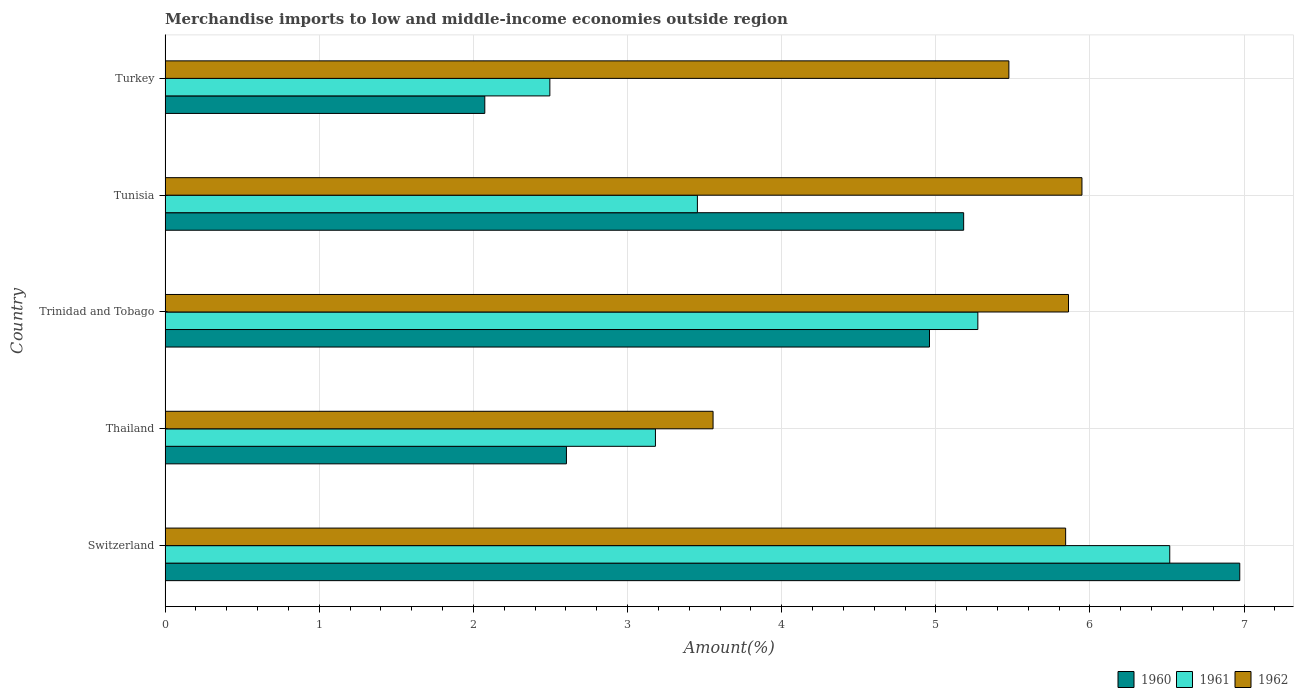How many different coloured bars are there?
Give a very brief answer. 3. Are the number of bars per tick equal to the number of legend labels?
Provide a short and direct response. Yes. How many bars are there on the 4th tick from the top?
Provide a succinct answer. 3. What is the label of the 1st group of bars from the top?
Make the answer very short. Turkey. What is the percentage of amount earned from merchandise imports in 1962 in Turkey?
Your answer should be very brief. 5.47. Across all countries, what is the maximum percentage of amount earned from merchandise imports in 1960?
Provide a short and direct response. 6.97. Across all countries, what is the minimum percentage of amount earned from merchandise imports in 1960?
Offer a very short reply. 2.07. In which country was the percentage of amount earned from merchandise imports in 1962 maximum?
Keep it short and to the point. Tunisia. What is the total percentage of amount earned from merchandise imports in 1962 in the graph?
Provide a short and direct response. 26.68. What is the difference between the percentage of amount earned from merchandise imports in 1962 in Trinidad and Tobago and that in Turkey?
Your answer should be very brief. 0.39. What is the difference between the percentage of amount earned from merchandise imports in 1961 in Thailand and the percentage of amount earned from merchandise imports in 1960 in Tunisia?
Offer a very short reply. -2. What is the average percentage of amount earned from merchandise imports in 1960 per country?
Give a very brief answer. 4.36. What is the difference between the percentage of amount earned from merchandise imports in 1961 and percentage of amount earned from merchandise imports in 1962 in Thailand?
Your answer should be very brief. -0.37. In how many countries, is the percentage of amount earned from merchandise imports in 1960 greater than 1.6 %?
Offer a very short reply. 5. What is the ratio of the percentage of amount earned from merchandise imports in 1962 in Thailand to that in Turkey?
Give a very brief answer. 0.65. Is the difference between the percentage of amount earned from merchandise imports in 1961 in Tunisia and Turkey greater than the difference between the percentage of amount earned from merchandise imports in 1962 in Tunisia and Turkey?
Keep it short and to the point. Yes. What is the difference between the highest and the second highest percentage of amount earned from merchandise imports in 1960?
Keep it short and to the point. 1.79. What is the difference between the highest and the lowest percentage of amount earned from merchandise imports in 1960?
Provide a short and direct response. 4.9. How many countries are there in the graph?
Keep it short and to the point. 5. Does the graph contain grids?
Provide a succinct answer. Yes. How are the legend labels stacked?
Ensure brevity in your answer.  Horizontal. What is the title of the graph?
Your answer should be compact. Merchandise imports to low and middle-income economies outside region. What is the label or title of the X-axis?
Offer a very short reply. Amount(%). What is the Amount(%) in 1960 in Switzerland?
Make the answer very short. 6.97. What is the Amount(%) in 1961 in Switzerland?
Give a very brief answer. 6.52. What is the Amount(%) of 1962 in Switzerland?
Provide a succinct answer. 5.84. What is the Amount(%) of 1960 in Thailand?
Provide a succinct answer. 2.6. What is the Amount(%) in 1961 in Thailand?
Keep it short and to the point. 3.18. What is the Amount(%) of 1962 in Thailand?
Provide a succinct answer. 3.55. What is the Amount(%) of 1960 in Trinidad and Tobago?
Make the answer very short. 4.96. What is the Amount(%) in 1961 in Trinidad and Tobago?
Offer a terse response. 5.27. What is the Amount(%) in 1962 in Trinidad and Tobago?
Ensure brevity in your answer.  5.86. What is the Amount(%) in 1960 in Tunisia?
Your answer should be compact. 5.18. What is the Amount(%) in 1961 in Tunisia?
Provide a succinct answer. 3.45. What is the Amount(%) in 1962 in Tunisia?
Provide a short and direct response. 5.95. What is the Amount(%) in 1960 in Turkey?
Provide a short and direct response. 2.07. What is the Amount(%) in 1961 in Turkey?
Make the answer very short. 2.5. What is the Amount(%) in 1962 in Turkey?
Give a very brief answer. 5.47. Across all countries, what is the maximum Amount(%) in 1960?
Ensure brevity in your answer.  6.97. Across all countries, what is the maximum Amount(%) of 1961?
Offer a very short reply. 6.52. Across all countries, what is the maximum Amount(%) of 1962?
Provide a short and direct response. 5.95. Across all countries, what is the minimum Amount(%) in 1960?
Offer a very short reply. 2.07. Across all countries, what is the minimum Amount(%) in 1961?
Offer a very short reply. 2.5. Across all countries, what is the minimum Amount(%) of 1962?
Provide a short and direct response. 3.55. What is the total Amount(%) in 1960 in the graph?
Offer a very short reply. 21.79. What is the total Amount(%) in 1961 in the graph?
Give a very brief answer. 20.92. What is the total Amount(%) of 1962 in the graph?
Your response must be concise. 26.68. What is the difference between the Amount(%) of 1960 in Switzerland and that in Thailand?
Provide a short and direct response. 4.37. What is the difference between the Amount(%) in 1961 in Switzerland and that in Thailand?
Provide a short and direct response. 3.34. What is the difference between the Amount(%) of 1962 in Switzerland and that in Thailand?
Keep it short and to the point. 2.29. What is the difference between the Amount(%) in 1960 in Switzerland and that in Trinidad and Tobago?
Your answer should be compact. 2.01. What is the difference between the Amount(%) of 1961 in Switzerland and that in Trinidad and Tobago?
Your response must be concise. 1.25. What is the difference between the Amount(%) in 1962 in Switzerland and that in Trinidad and Tobago?
Your answer should be compact. -0.02. What is the difference between the Amount(%) of 1960 in Switzerland and that in Tunisia?
Offer a terse response. 1.79. What is the difference between the Amount(%) in 1961 in Switzerland and that in Tunisia?
Provide a short and direct response. 3.06. What is the difference between the Amount(%) of 1962 in Switzerland and that in Tunisia?
Offer a very short reply. -0.11. What is the difference between the Amount(%) of 1960 in Switzerland and that in Turkey?
Your response must be concise. 4.9. What is the difference between the Amount(%) of 1961 in Switzerland and that in Turkey?
Give a very brief answer. 4.02. What is the difference between the Amount(%) of 1962 in Switzerland and that in Turkey?
Ensure brevity in your answer.  0.37. What is the difference between the Amount(%) of 1960 in Thailand and that in Trinidad and Tobago?
Make the answer very short. -2.36. What is the difference between the Amount(%) in 1961 in Thailand and that in Trinidad and Tobago?
Provide a short and direct response. -2.09. What is the difference between the Amount(%) in 1962 in Thailand and that in Trinidad and Tobago?
Provide a succinct answer. -2.31. What is the difference between the Amount(%) of 1960 in Thailand and that in Tunisia?
Provide a succinct answer. -2.58. What is the difference between the Amount(%) in 1961 in Thailand and that in Tunisia?
Give a very brief answer. -0.27. What is the difference between the Amount(%) of 1962 in Thailand and that in Tunisia?
Your answer should be compact. -2.39. What is the difference between the Amount(%) in 1960 in Thailand and that in Turkey?
Offer a very short reply. 0.53. What is the difference between the Amount(%) of 1961 in Thailand and that in Turkey?
Keep it short and to the point. 0.69. What is the difference between the Amount(%) in 1962 in Thailand and that in Turkey?
Provide a short and direct response. -1.92. What is the difference between the Amount(%) in 1960 in Trinidad and Tobago and that in Tunisia?
Give a very brief answer. -0.22. What is the difference between the Amount(%) in 1961 in Trinidad and Tobago and that in Tunisia?
Your response must be concise. 1.82. What is the difference between the Amount(%) in 1962 in Trinidad and Tobago and that in Tunisia?
Keep it short and to the point. -0.09. What is the difference between the Amount(%) in 1960 in Trinidad and Tobago and that in Turkey?
Provide a short and direct response. 2.88. What is the difference between the Amount(%) in 1961 in Trinidad and Tobago and that in Turkey?
Offer a terse response. 2.78. What is the difference between the Amount(%) in 1962 in Trinidad and Tobago and that in Turkey?
Your answer should be compact. 0.39. What is the difference between the Amount(%) in 1960 in Tunisia and that in Turkey?
Provide a short and direct response. 3.11. What is the difference between the Amount(%) of 1961 in Tunisia and that in Turkey?
Give a very brief answer. 0.96. What is the difference between the Amount(%) in 1962 in Tunisia and that in Turkey?
Your response must be concise. 0.47. What is the difference between the Amount(%) in 1960 in Switzerland and the Amount(%) in 1961 in Thailand?
Offer a terse response. 3.79. What is the difference between the Amount(%) of 1960 in Switzerland and the Amount(%) of 1962 in Thailand?
Your answer should be compact. 3.42. What is the difference between the Amount(%) of 1961 in Switzerland and the Amount(%) of 1962 in Thailand?
Offer a very short reply. 2.96. What is the difference between the Amount(%) in 1960 in Switzerland and the Amount(%) in 1961 in Trinidad and Tobago?
Keep it short and to the point. 1.7. What is the difference between the Amount(%) in 1960 in Switzerland and the Amount(%) in 1962 in Trinidad and Tobago?
Make the answer very short. 1.11. What is the difference between the Amount(%) of 1961 in Switzerland and the Amount(%) of 1962 in Trinidad and Tobago?
Your answer should be very brief. 0.66. What is the difference between the Amount(%) in 1960 in Switzerland and the Amount(%) in 1961 in Tunisia?
Your answer should be compact. 3.52. What is the difference between the Amount(%) in 1960 in Switzerland and the Amount(%) in 1962 in Tunisia?
Keep it short and to the point. 1.02. What is the difference between the Amount(%) of 1961 in Switzerland and the Amount(%) of 1962 in Tunisia?
Offer a terse response. 0.57. What is the difference between the Amount(%) of 1960 in Switzerland and the Amount(%) of 1961 in Turkey?
Offer a terse response. 4.48. What is the difference between the Amount(%) of 1960 in Switzerland and the Amount(%) of 1962 in Turkey?
Ensure brevity in your answer.  1.5. What is the difference between the Amount(%) in 1961 in Switzerland and the Amount(%) in 1962 in Turkey?
Your response must be concise. 1.04. What is the difference between the Amount(%) in 1960 in Thailand and the Amount(%) in 1961 in Trinidad and Tobago?
Make the answer very short. -2.67. What is the difference between the Amount(%) in 1960 in Thailand and the Amount(%) in 1962 in Trinidad and Tobago?
Give a very brief answer. -3.26. What is the difference between the Amount(%) in 1961 in Thailand and the Amount(%) in 1962 in Trinidad and Tobago?
Make the answer very short. -2.68. What is the difference between the Amount(%) in 1960 in Thailand and the Amount(%) in 1961 in Tunisia?
Offer a very short reply. -0.85. What is the difference between the Amount(%) in 1960 in Thailand and the Amount(%) in 1962 in Tunisia?
Offer a very short reply. -3.34. What is the difference between the Amount(%) in 1961 in Thailand and the Amount(%) in 1962 in Tunisia?
Provide a short and direct response. -2.77. What is the difference between the Amount(%) of 1960 in Thailand and the Amount(%) of 1961 in Turkey?
Keep it short and to the point. 0.11. What is the difference between the Amount(%) in 1960 in Thailand and the Amount(%) in 1962 in Turkey?
Your answer should be compact. -2.87. What is the difference between the Amount(%) in 1961 in Thailand and the Amount(%) in 1962 in Turkey?
Provide a short and direct response. -2.29. What is the difference between the Amount(%) in 1960 in Trinidad and Tobago and the Amount(%) in 1961 in Tunisia?
Provide a succinct answer. 1.51. What is the difference between the Amount(%) in 1960 in Trinidad and Tobago and the Amount(%) in 1962 in Tunisia?
Offer a very short reply. -0.99. What is the difference between the Amount(%) in 1961 in Trinidad and Tobago and the Amount(%) in 1962 in Tunisia?
Give a very brief answer. -0.68. What is the difference between the Amount(%) in 1960 in Trinidad and Tobago and the Amount(%) in 1961 in Turkey?
Provide a short and direct response. 2.46. What is the difference between the Amount(%) in 1960 in Trinidad and Tobago and the Amount(%) in 1962 in Turkey?
Offer a terse response. -0.52. What is the difference between the Amount(%) in 1961 in Trinidad and Tobago and the Amount(%) in 1962 in Turkey?
Make the answer very short. -0.2. What is the difference between the Amount(%) of 1960 in Tunisia and the Amount(%) of 1961 in Turkey?
Offer a terse response. 2.68. What is the difference between the Amount(%) of 1960 in Tunisia and the Amount(%) of 1962 in Turkey?
Ensure brevity in your answer.  -0.29. What is the difference between the Amount(%) in 1961 in Tunisia and the Amount(%) in 1962 in Turkey?
Provide a short and direct response. -2.02. What is the average Amount(%) in 1960 per country?
Make the answer very short. 4.36. What is the average Amount(%) of 1961 per country?
Your answer should be very brief. 4.18. What is the average Amount(%) in 1962 per country?
Your response must be concise. 5.34. What is the difference between the Amount(%) of 1960 and Amount(%) of 1961 in Switzerland?
Offer a very short reply. 0.45. What is the difference between the Amount(%) of 1960 and Amount(%) of 1962 in Switzerland?
Offer a very short reply. 1.13. What is the difference between the Amount(%) of 1961 and Amount(%) of 1962 in Switzerland?
Your response must be concise. 0.68. What is the difference between the Amount(%) in 1960 and Amount(%) in 1961 in Thailand?
Ensure brevity in your answer.  -0.58. What is the difference between the Amount(%) in 1960 and Amount(%) in 1962 in Thailand?
Keep it short and to the point. -0.95. What is the difference between the Amount(%) of 1961 and Amount(%) of 1962 in Thailand?
Provide a short and direct response. -0.37. What is the difference between the Amount(%) of 1960 and Amount(%) of 1961 in Trinidad and Tobago?
Provide a succinct answer. -0.31. What is the difference between the Amount(%) of 1960 and Amount(%) of 1962 in Trinidad and Tobago?
Your answer should be very brief. -0.9. What is the difference between the Amount(%) of 1961 and Amount(%) of 1962 in Trinidad and Tobago?
Provide a succinct answer. -0.59. What is the difference between the Amount(%) in 1960 and Amount(%) in 1961 in Tunisia?
Offer a very short reply. 1.73. What is the difference between the Amount(%) of 1960 and Amount(%) of 1962 in Tunisia?
Offer a terse response. -0.77. What is the difference between the Amount(%) in 1961 and Amount(%) in 1962 in Tunisia?
Ensure brevity in your answer.  -2.49. What is the difference between the Amount(%) in 1960 and Amount(%) in 1961 in Turkey?
Your answer should be compact. -0.42. What is the difference between the Amount(%) in 1960 and Amount(%) in 1962 in Turkey?
Your answer should be compact. -3.4. What is the difference between the Amount(%) in 1961 and Amount(%) in 1962 in Turkey?
Your answer should be compact. -2.98. What is the ratio of the Amount(%) in 1960 in Switzerland to that in Thailand?
Offer a very short reply. 2.68. What is the ratio of the Amount(%) of 1961 in Switzerland to that in Thailand?
Your answer should be very brief. 2.05. What is the ratio of the Amount(%) in 1962 in Switzerland to that in Thailand?
Your answer should be very brief. 1.64. What is the ratio of the Amount(%) in 1960 in Switzerland to that in Trinidad and Tobago?
Ensure brevity in your answer.  1.41. What is the ratio of the Amount(%) in 1961 in Switzerland to that in Trinidad and Tobago?
Provide a succinct answer. 1.24. What is the ratio of the Amount(%) of 1962 in Switzerland to that in Trinidad and Tobago?
Your response must be concise. 1. What is the ratio of the Amount(%) of 1960 in Switzerland to that in Tunisia?
Give a very brief answer. 1.35. What is the ratio of the Amount(%) in 1961 in Switzerland to that in Tunisia?
Make the answer very short. 1.89. What is the ratio of the Amount(%) of 1962 in Switzerland to that in Tunisia?
Ensure brevity in your answer.  0.98. What is the ratio of the Amount(%) of 1960 in Switzerland to that in Turkey?
Your answer should be compact. 3.36. What is the ratio of the Amount(%) of 1961 in Switzerland to that in Turkey?
Make the answer very short. 2.61. What is the ratio of the Amount(%) in 1962 in Switzerland to that in Turkey?
Provide a succinct answer. 1.07. What is the ratio of the Amount(%) in 1960 in Thailand to that in Trinidad and Tobago?
Provide a short and direct response. 0.53. What is the ratio of the Amount(%) in 1961 in Thailand to that in Trinidad and Tobago?
Your answer should be compact. 0.6. What is the ratio of the Amount(%) in 1962 in Thailand to that in Trinidad and Tobago?
Your answer should be very brief. 0.61. What is the ratio of the Amount(%) in 1960 in Thailand to that in Tunisia?
Make the answer very short. 0.5. What is the ratio of the Amount(%) in 1961 in Thailand to that in Tunisia?
Provide a short and direct response. 0.92. What is the ratio of the Amount(%) in 1962 in Thailand to that in Tunisia?
Your response must be concise. 0.6. What is the ratio of the Amount(%) in 1960 in Thailand to that in Turkey?
Give a very brief answer. 1.26. What is the ratio of the Amount(%) of 1961 in Thailand to that in Turkey?
Your answer should be compact. 1.27. What is the ratio of the Amount(%) of 1962 in Thailand to that in Turkey?
Your response must be concise. 0.65. What is the ratio of the Amount(%) of 1960 in Trinidad and Tobago to that in Tunisia?
Keep it short and to the point. 0.96. What is the ratio of the Amount(%) of 1961 in Trinidad and Tobago to that in Tunisia?
Ensure brevity in your answer.  1.53. What is the ratio of the Amount(%) in 1960 in Trinidad and Tobago to that in Turkey?
Keep it short and to the point. 2.39. What is the ratio of the Amount(%) in 1961 in Trinidad and Tobago to that in Turkey?
Ensure brevity in your answer.  2.11. What is the ratio of the Amount(%) in 1962 in Trinidad and Tobago to that in Turkey?
Keep it short and to the point. 1.07. What is the ratio of the Amount(%) in 1960 in Tunisia to that in Turkey?
Give a very brief answer. 2.5. What is the ratio of the Amount(%) in 1961 in Tunisia to that in Turkey?
Your answer should be compact. 1.38. What is the ratio of the Amount(%) of 1962 in Tunisia to that in Turkey?
Your answer should be compact. 1.09. What is the difference between the highest and the second highest Amount(%) in 1960?
Ensure brevity in your answer.  1.79. What is the difference between the highest and the second highest Amount(%) in 1961?
Your answer should be compact. 1.25. What is the difference between the highest and the second highest Amount(%) of 1962?
Ensure brevity in your answer.  0.09. What is the difference between the highest and the lowest Amount(%) of 1960?
Your answer should be compact. 4.9. What is the difference between the highest and the lowest Amount(%) in 1961?
Make the answer very short. 4.02. What is the difference between the highest and the lowest Amount(%) of 1962?
Your answer should be very brief. 2.39. 